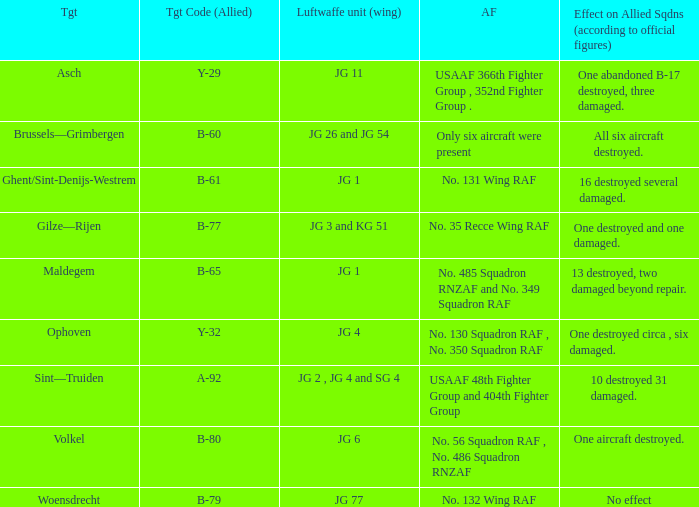What is the allied target code of the group that targetted ghent/sint-denijs-westrem? B-61. 